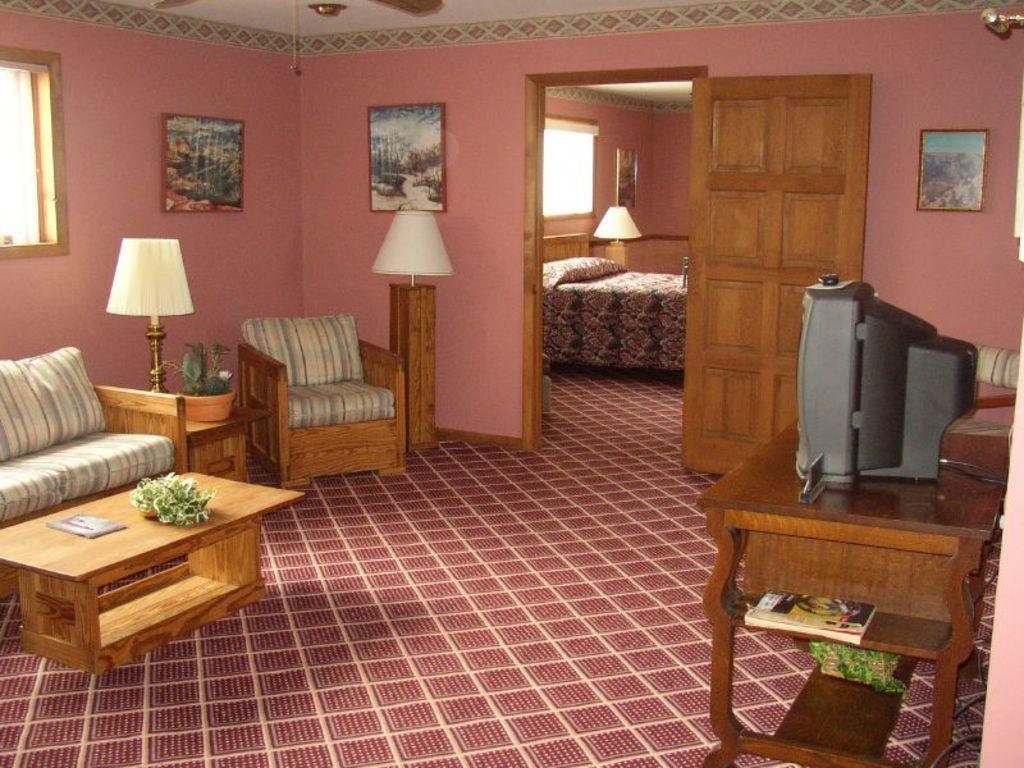In one or two sentences, can you explain what this image depicts? In this image we can see a sofa, chair, some plants, books, a television on a table, the lamps, windows and some photo frames on the walls. We can also see a door, a bed with a pillow on it, a ceiling light and a ceiling fan to a roof. 